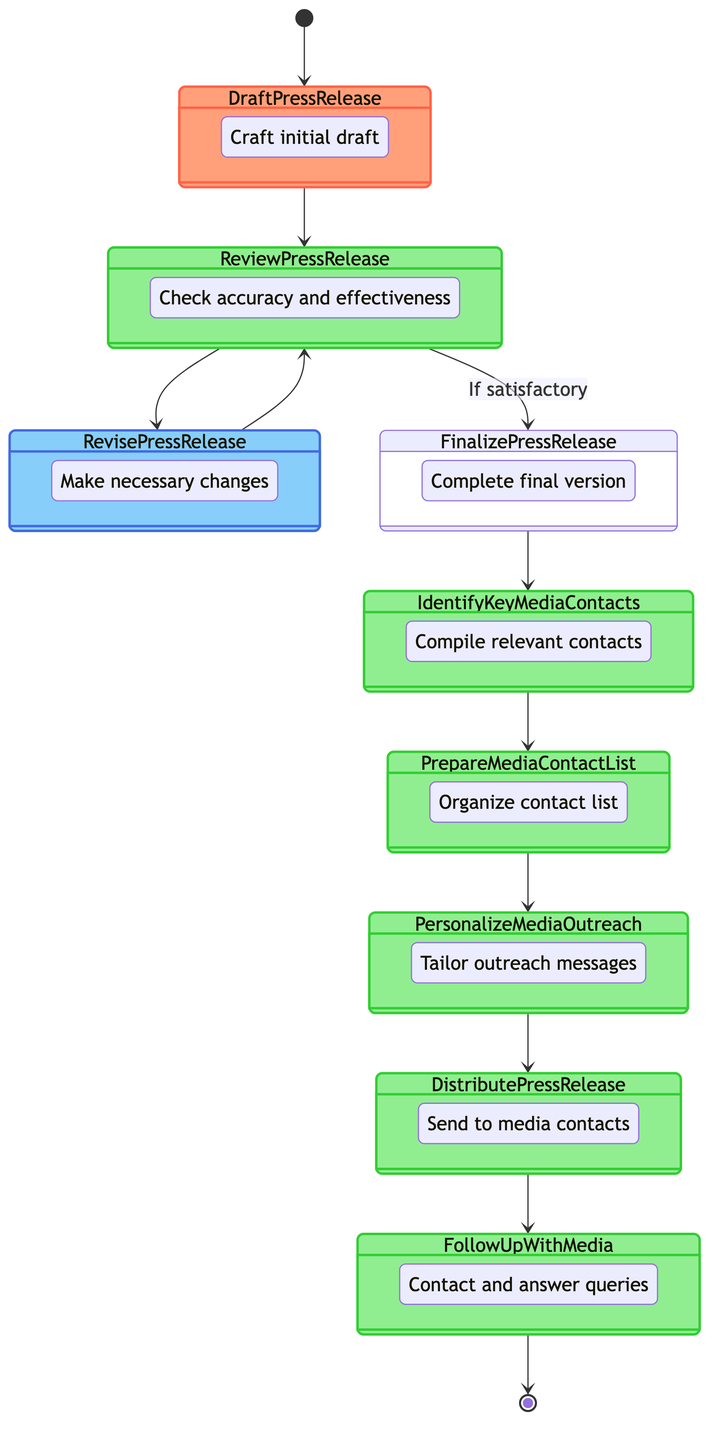How many nodes are in the diagram? The diagram has a total of 11 nodes, which include one Start, one End, several activities, and a decision node.
Answer: 11 What is the last activity before ending the process? The last activity before ending the process is "Follow Up with Media," which comes immediately before the End Process node.
Answer: Follow Up with Media What type of node is "Review Press Release"? The "Review Press Release" is classified as a Decision node in the diagram, indicating a point where a choice must be made based on the review.
Answer: Decision Which activity directly follows "Identify Key Media Contacts"? The activity that directly follows "Identify Key Media Contacts" is "Prepare Media Contact List," according to the flow sequence in the diagram.
Answer: Prepare Media Contact List What condition must be met to move from "Review Press Release" to "Finalize Press Release"? The condition that must be satisfied to move from "Review Press Release" to "Finalize Press Release" is that the review must be satisfactory, indicating approval of the draft.
Answer: If satisfactory What activities are involved in personalizing media outreach? The activity involved in personalizing media outreach is "Personalize Media Outreach," which is only preceded by the "Prepare Media Contact List" activity in the flow.
Answer: Personalize Media Outreach How many activities are included in the process? There are a total of 8 activities in the process which encompass drafting, reviewing, finalizing the press release, identifying media contacts, and other outreach steps.
Answer: 8 At which point does the process start? The process starts at the "Start Process" node, which serves as the initial point of the activity diagram.
Answer: Start Process 